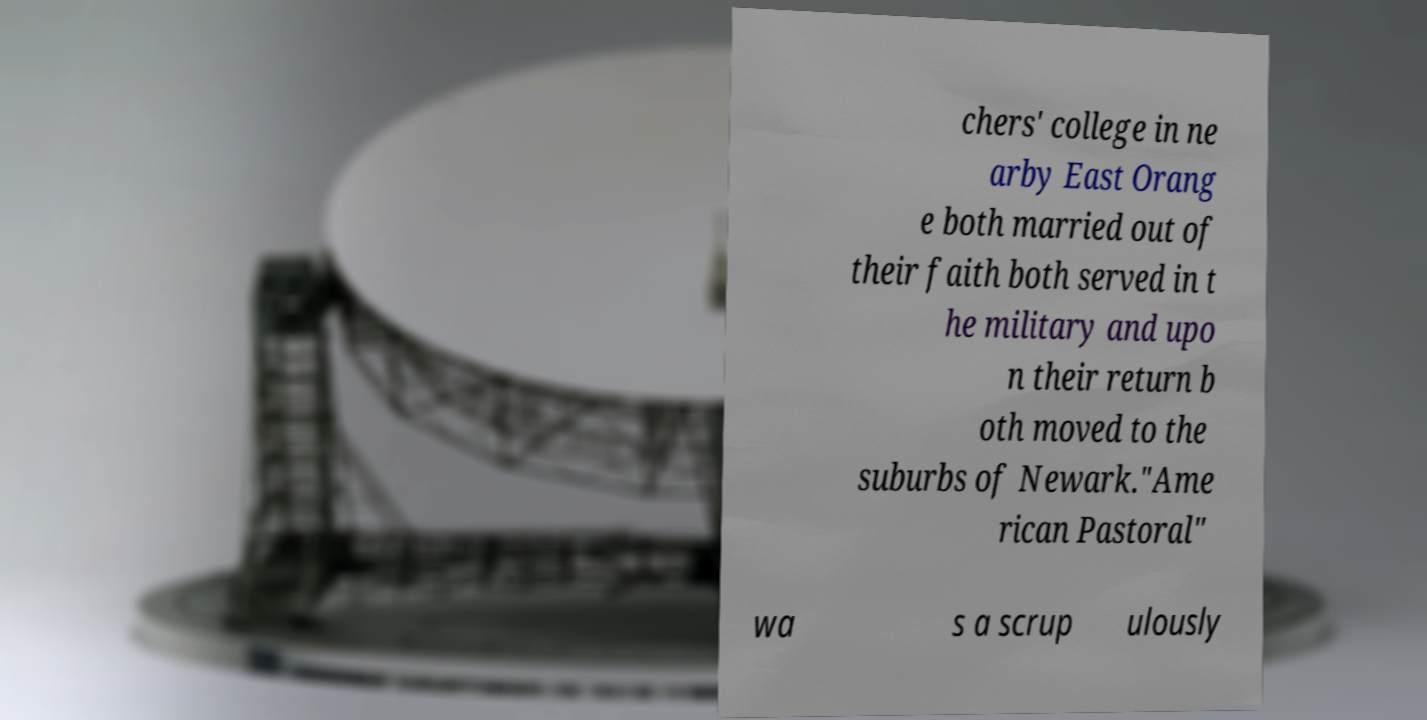I need the written content from this picture converted into text. Can you do that? chers' college in ne arby East Orang e both married out of their faith both served in t he military and upo n their return b oth moved to the suburbs of Newark."Ame rican Pastoral" wa s a scrup ulously 